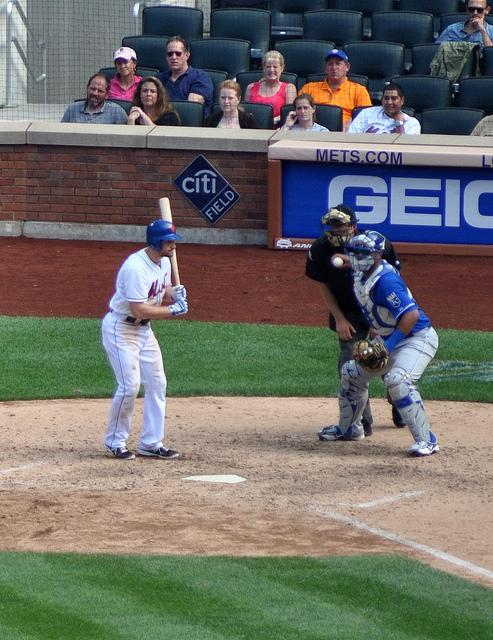Whose home field stadium is this? mets 